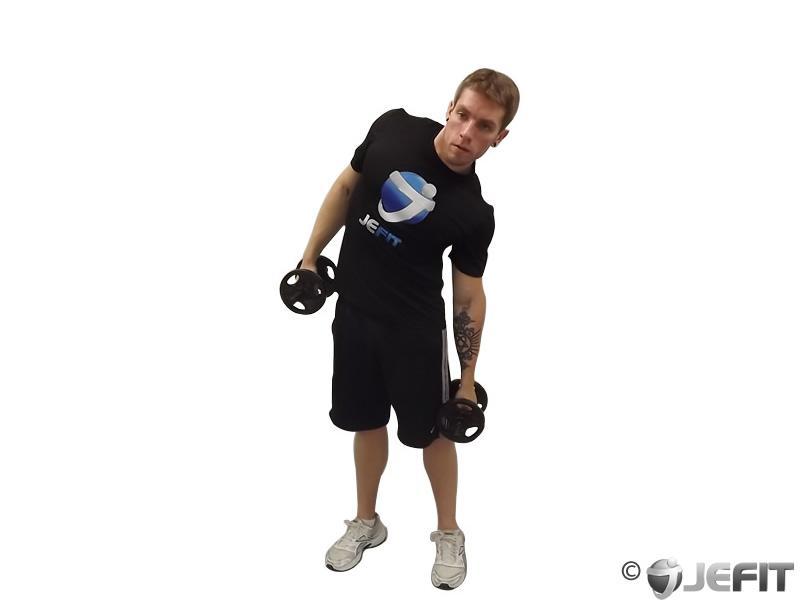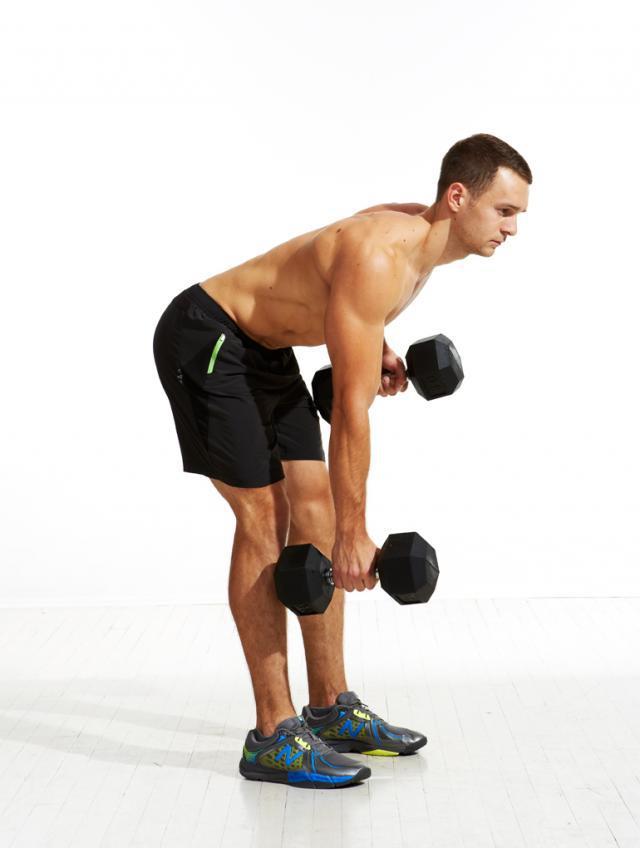The first image is the image on the left, the second image is the image on the right. For the images displayed, is the sentence "There are more people in the image on the right." factually correct? Answer yes or no. No. 